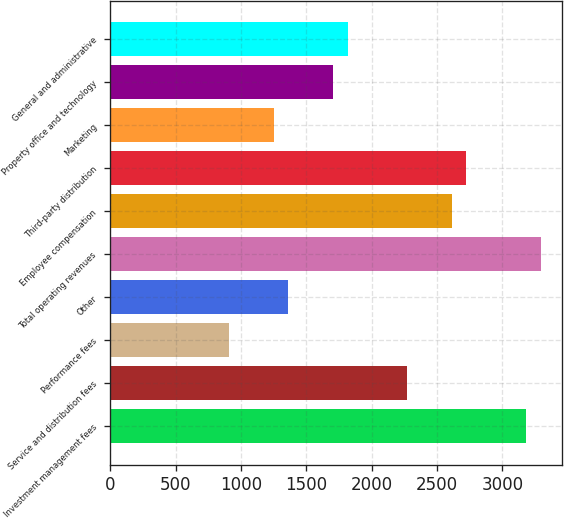Convert chart to OTSL. <chart><loc_0><loc_0><loc_500><loc_500><bar_chart><fcel>Investment management fees<fcel>Service and distribution fees<fcel>Performance fees<fcel>Other<fcel>Total operating revenues<fcel>Employee compensation<fcel>Third-party distribution<fcel>Marketing<fcel>Property office and technology<fcel>General and administrative<nl><fcel>3179.07<fcel>2270.83<fcel>908.47<fcel>1362.59<fcel>3292.6<fcel>2611.42<fcel>2724.95<fcel>1249.06<fcel>1703.18<fcel>1816.71<nl></chart> 